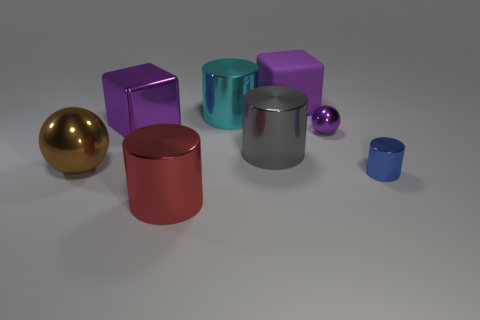There is a gray metal object; does it have the same shape as the red thing in front of the large cyan cylinder?
Keep it short and to the point. Yes. What number of spheres are the same size as the brown object?
Your answer should be compact. 0. There is a blue thing that is the same shape as the gray object; what material is it?
Offer a very short reply. Metal. There is a cube that is right of the big red cylinder; is it the same color as the sphere behind the brown thing?
Provide a succinct answer. Yes. What is the shape of the large purple thing in front of the matte thing?
Your response must be concise. Cube. What color is the matte block?
Offer a very short reply. Purple. What shape is the cyan thing that is made of the same material as the purple sphere?
Offer a terse response. Cylinder. Does the shiny ball behind the gray metal object have the same size as the blue metallic object?
Your response must be concise. Yes. How many objects are tiny metallic things behind the tiny blue thing or large objects that are right of the red thing?
Provide a short and direct response. 4. There is a large thing that is on the right side of the big gray shiny object; is it the same color as the tiny metallic ball?
Your answer should be compact. Yes. 